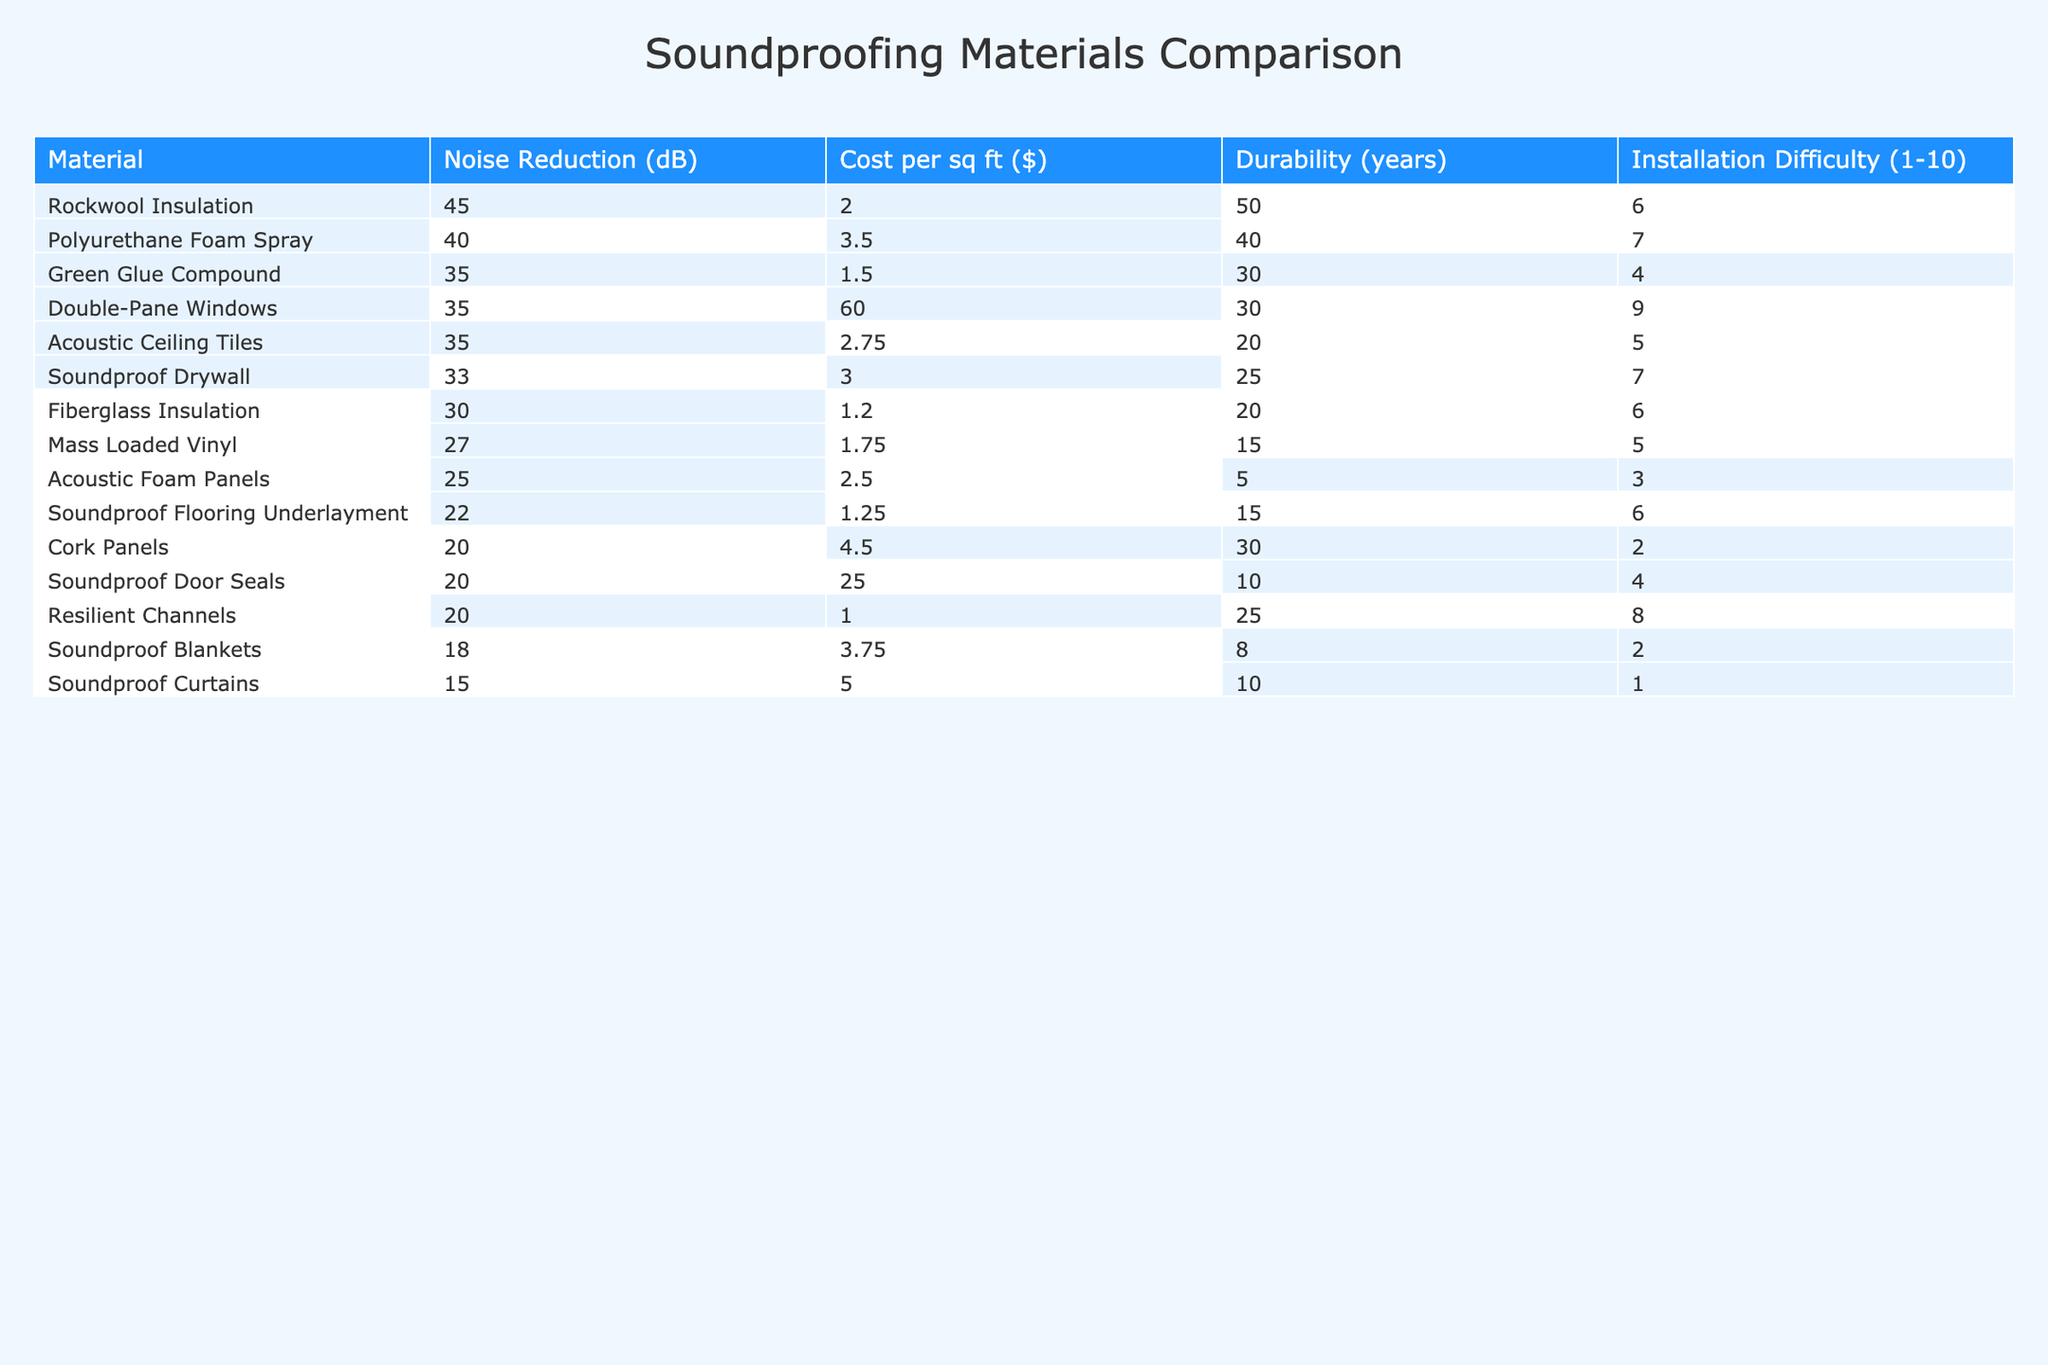What is the noise reduction level of Soundproof Drywall? The table shows that Soundproof Drywall has a noise reduction level of 33 dB, as indicated in the corresponding column for that material.
Answer: 33 dB Which material has the lowest cost per square foot? By looking at the Cost per sq ft column, Fiberglass Insulation has the lowest cost at $1.20 per square foot.
Answer: $1.20 How many materials have a noise reduction greater than 30 dB? Referring to the table, the materials with noise reduction greater than 30 dB are Mass Loaded Vinyl, Fiberglass Insulation, Soundproof Drywall, Green Glue Compound, Rockwool Insulation, Polyurethane Foam Spray, Double-Pane Windows, and Acoustic Ceiling Tiles—totaling 8 materials.
Answer: 8 What is the average cost per square foot of the materials listed? To find the average cost, sum all the costs: $2.50 + $1.75 + $1.20 + $3.00 + $1.50 + $2.00 + $4.50 + $5.00 + $60.00 + $2.75 + $25.00 + $1.00 + $1.25 + $3.50 + $3.75 = $113.25 for 15 materials. Thus, the average is $113.25 / 15 ≈ $7.55.
Answer: $7.55 Is the installation difficulty of Polyurethane Foam Spray less than 5? The installation difficulty for Polyurethane Foam Spray is indicated in the table as 7, which is higher than 5. Therefore, the answer is no.
Answer: No Which soundproofing material has the highest durability and how many years does it last? The table indicates that Rockwool Insulation has the highest durability at 50 years, as shown in the corresponding durability column.
Answer: 50 years Are there any materials with a noise reduction of 20 dB or less? Referring to the table, Soundproof Curtains (15 dB) and Cork Panels (20 dB) have a noise reduction of 20 dB or less, confirming that the answer is yes.
Answer: Yes What is the total durability of all materials combined? To find the total durability, sum all the durability values: 5 + 15 + 20 + 25 + 30 + 50 + 30 + 10 + 30 + 20 + 10 + 25 + 15 + 40 + 8 =  8 =  6 + 5 + 30 + 15 = 374 years.
Answer: 374 years Which material offers the best noise reduction relative to its cost? To determine this, calculate the noise reduction per dollar for each material. For instance, Acoustic Foam Panels give 25 dB/$2.50 = 10 dB per dollar, while Rockwool Insulation gives 45 dB/$2.00 = 22.5 dB per dollar. Comparing all ratios, Rockwool Insulation gives the highest noise reduction per dollar spent.
Answer: Rockwool Insulation How many materials have a noise reduction greater than 30 dB and a cost of less than $3 per sq ft? From the table, the materials that meet both criteria are Mass Loaded Vinyl (27 dB, $1.75), Fiberglass Insulation (30 dB, $1.20), Rockwool Insulation (45 dB, $2.00), and Acoustic Ceiling Tiles (35 dB, $2.75) totaling 4 materials.
Answer: 4 Does the cost always correlate with durability for the listed materials? A visual inspection of the table shows that while some durable materials are low-cost (e.g., Rockwool Insulation), others are expensive with lower durability (e.g., Soundproof Curtains), indicating no consistent correlation.
Answer: No 